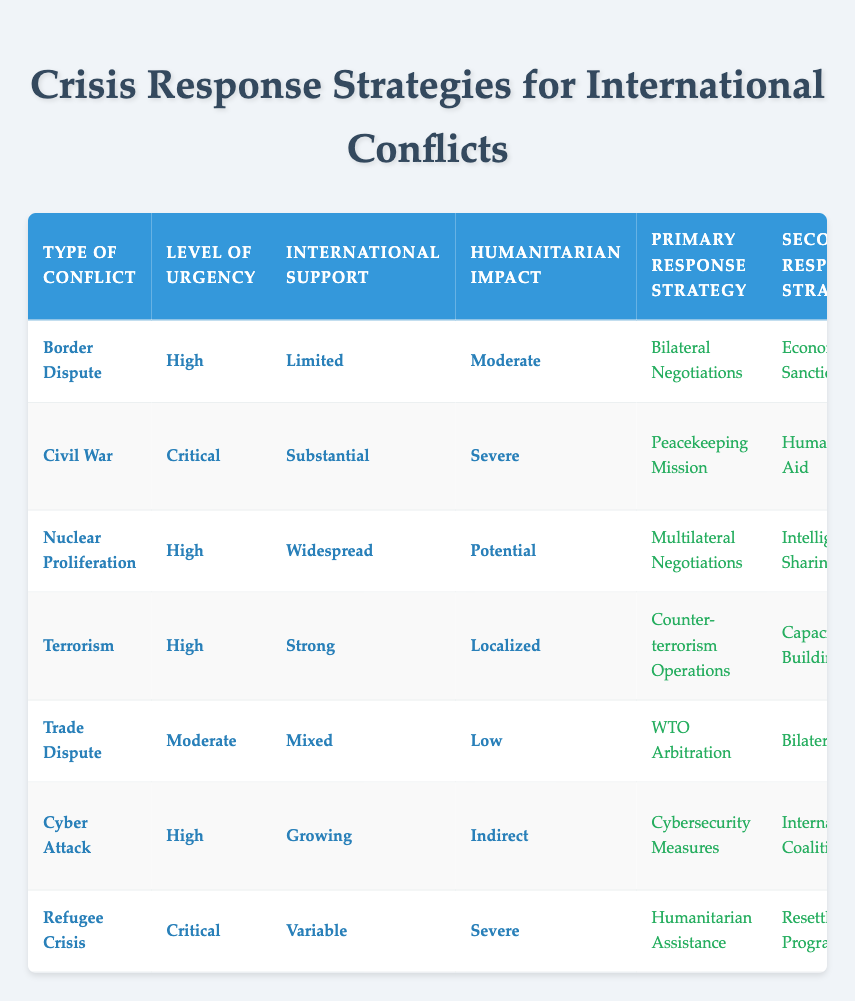What is the primary response strategy for a civil war? The table indicates that for a civil war, the primary response strategy is a "Peacekeeping Mission." This can be found in the row corresponding to the type of conflict labeled "Civil War."
Answer: Peacekeeping Mission Which type of conflict has the highest level of urgency according to the table? The conflicts classified as "Critical" urgency levels are Civil War and Refugee Crisis. However, Civil War is the only one categorized as "Critical," which is the highest urgency category.
Answer: Civil War Is there any international support for border disputes listed in the table? According to the information in the row for "Border Dispute," the international support is classified as "Limited." Thus, there is some level of international support, but it is not strong.
Answer: Yes What are the secondary response strategies for terrorism and cyber attacks? From the table, for terrorism, the secondary response strategy is "Capacity Building." For cyber attacks, it is "International Coalition." These are found in the respective rows for "Terrorism" and "Cyber Attack."
Answer: Capacity Building; International Coalition Which type of conflict involves substantial international support and severe humanitarian impact? The "Civil War" type of conflict has "Substantial" international support and "Severe" humanitarian impact according to its corresponding values in the table.
Answer: Civil War How many conflicts have "High" as their level of urgency? By examining the table, the conflicts classified with "High" urgency levels include Border Dispute, Nuclear Proliferation, Terrorism, and Cyber Attack. Therefore, there are four conflicts with this level of urgency.
Answer: Four Is UN involvement present in the case of a trade dispute? The table states that for the "Trade Dispute," there is "None" listed under UN involvement. This indicates that the UN is not involved in this type of conflict.
Answer: No Which conflict has the most severe humanitarian impact and what is the primary response strategy? The conflicts with the most severe humanitarian impact are Civil War and Refugee Crisis. The primary response strategy for the Civil War is "Peacekeeping Mission" while for Refugee Crisis it's "Humanitarian Assistance."
Answer: Civil War; Peacekeeping Mission; Refugee Crisis; Humanitarian Assistance How does the level of urgency compare between terrorism and nuclear proliferation? Terrorism is categorized with a "High" level of urgency, whereas Nuclear Proliferation is also classified as "High." Therefore, both types share the same urgency level.
Answer: They are both High 